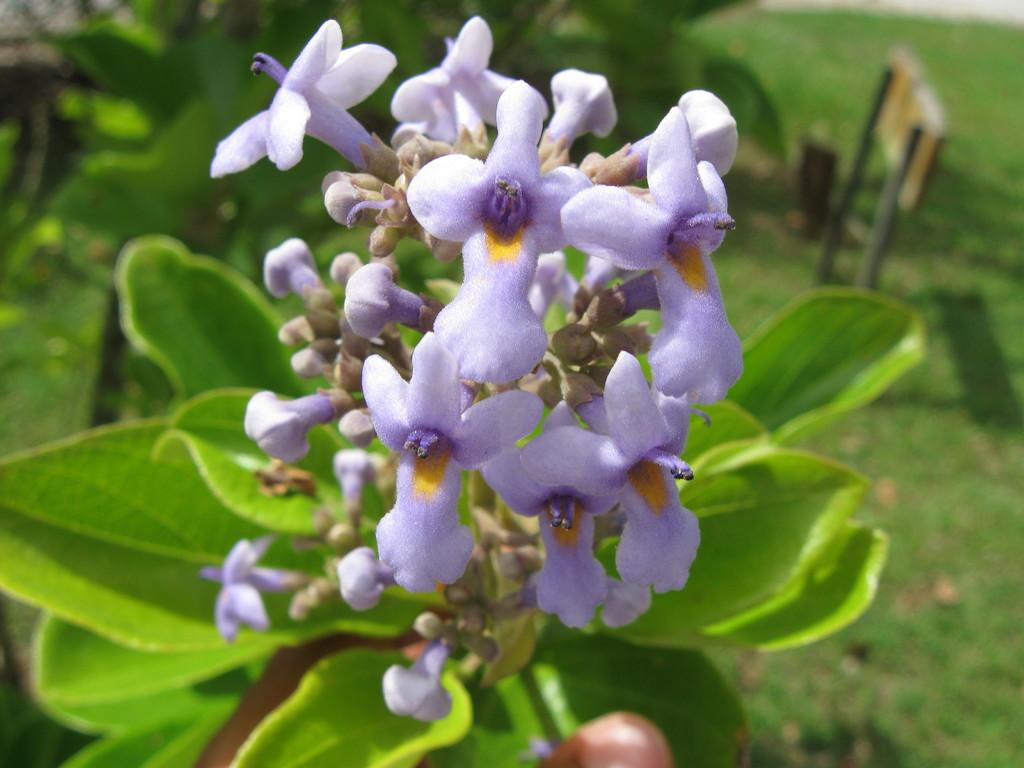What type of flowers can be seen in the image? There are purple color flowers in the image. What else can be found in the image besides the flowers? There are leaves in the image. What type of pleasure can be experienced by the flowers in the image? The flowers in the image are not capable of experiencing pleasure, as they are inanimate objects. 